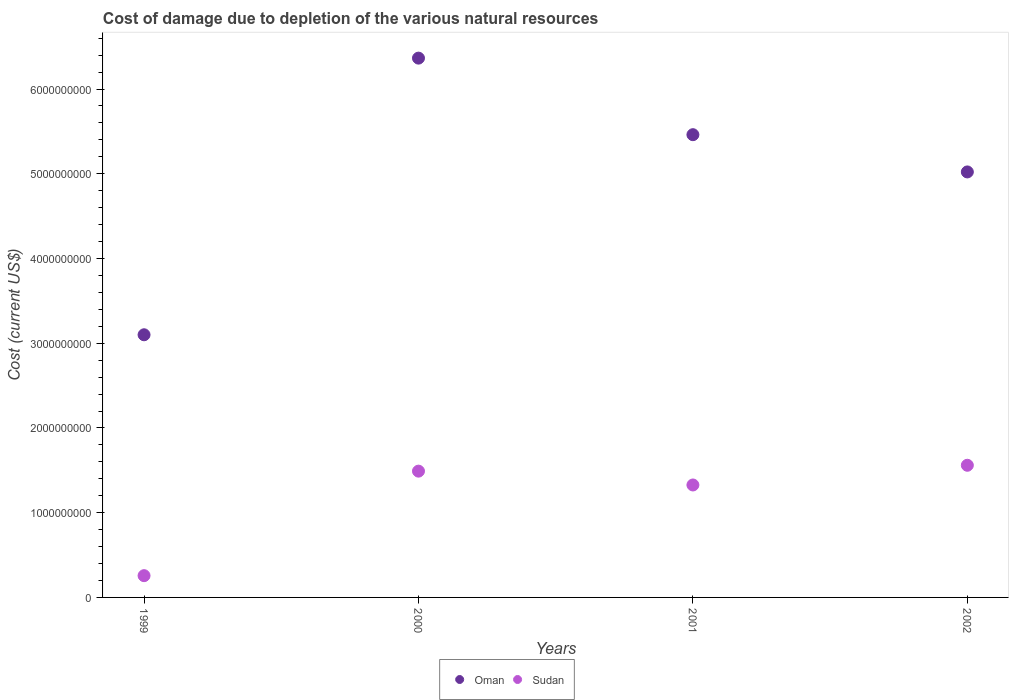How many different coloured dotlines are there?
Provide a succinct answer. 2. What is the cost of damage caused due to the depletion of various natural resources in Sudan in 2001?
Your response must be concise. 1.33e+09. Across all years, what is the maximum cost of damage caused due to the depletion of various natural resources in Sudan?
Give a very brief answer. 1.56e+09. Across all years, what is the minimum cost of damage caused due to the depletion of various natural resources in Oman?
Offer a very short reply. 3.10e+09. In which year was the cost of damage caused due to the depletion of various natural resources in Oman maximum?
Your answer should be compact. 2000. In which year was the cost of damage caused due to the depletion of various natural resources in Oman minimum?
Provide a short and direct response. 1999. What is the total cost of damage caused due to the depletion of various natural resources in Sudan in the graph?
Make the answer very short. 4.63e+09. What is the difference between the cost of damage caused due to the depletion of various natural resources in Sudan in 1999 and that in 2002?
Your answer should be compact. -1.30e+09. What is the difference between the cost of damage caused due to the depletion of various natural resources in Oman in 1999 and the cost of damage caused due to the depletion of various natural resources in Sudan in 2000?
Your answer should be compact. 1.61e+09. What is the average cost of damage caused due to the depletion of various natural resources in Sudan per year?
Make the answer very short. 1.16e+09. In the year 1999, what is the difference between the cost of damage caused due to the depletion of various natural resources in Sudan and cost of damage caused due to the depletion of various natural resources in Oman?
Your answer should be compact. -2.84e+09. What is the ratio of the cost of damage caused due to the depletion of various natural resources in Sudan in 1999 to that in 2002?
Give a very brief answer. 0.16. Is the difference between the cost of damage caused due to the depletion of various natural resources in Sudan in 1999 and 2000 greater than the difference between the cost of damage caused due to the depletion of various natural resources in Oman in 1999 and 2000?
Offer a very short reply. Yes. What is the difference between the highest and the second highest cost of damage caused due to the depletion of various natural resources in Sudan?
Offer a very short reply. 6.93e+07. What is the difference between the highest and the lowest cost of damage caused due to the depletion of various natural resources in Sudan?
Give a very brief answer. 1.30e+09. In how many years, is the cost of damage caused due to the depletion of various natural resources in Oman greater than the average cost of damage caused due to the depletion of various natural resources in Oman taken over all years?
Keep it short and to the point. 3. Is the sum of the cost of damage caused due to the depletion of various natural resources in Oman in 2001 and 2002 greater than the maximum cost of damage caused due to the depletion of various natural resources in Sudan across all years?
Keep it short and to the point. Yes. Does the cost of damage caused due to the depletion of various natural resources in Oman monotonically increase over the years?
Make the answer very short. No. Is the cost of damage caused due to the depletion of various natural resources in Oman strictly less than the cost of damage caused due to the depletion of various natural resources in Sudan over the years?
Your answer should be very brief. No. How many dotlines are there?
Keep it short and to the point. 2. What is the difference between two consecutive major ticks on the Y-axis?
Your response must be concise. 1.00e+09. Where does the legend appear in the graph?
Keep it short and to the point. Bottom center. What is the title of the graph?
Give a very brief answer. Cost of damage due to depletion of the various natural resources. What is the label or title of the Y-axis?
Offer a terse response. Cost (current US$). What is the Cost (current US$) in Oman in 1999?
Ensure brevity in your answer.  3.10e+09. What is the Cost (current US$) of Sudan in 1999?
Provide a short and direct response. 2.57e+08. What is the Cost (current US$) in Oman in 2000?
Give a very brief answer. 6.36e+09. What is the Cost (current US$) of Sudan in 2000?
Your answer should be compact. 1.49e+09. What is the Cost (current US$) in Oman in 2001?
Your answer should be compact. 5.46e+09. What is the Cost (current US$) in Sudan in 2001?
Provide a succinct answer. 1.33e+09. What is the Cost (current US$) in Oman in 2002?
Offer a very short reply. 5.02e+09. What is the Cost (current US$) of Sudan in 2002?
Your response must be concise. 1.56e+09. Across all years, what is the maximum Cost (current US$) of Oman?
Make the answer very short. 6.36e+09. Across all years, what is the maximum Cost (current US$) in Sudan?
Give a very brief answer. 1.56e+09. Across all years, what is the minimum Cost (current US$) of Oman?
Your response must be concise. 3.10e+09. Across all years, what is the minimum Cost (current US$) of Sudan?
Make the answer very short. 2.57e+08. What is the total Cost (current US$) in Oman in the graph?
Offer a very short reply. 1.99e+1. What is the total Cost (current US$) in Sudan in the graph?
Your answer should be compact. 4.63e+09. What is the difference between the Cost (current US$) of Oman in 1999 and that in 2000?
Give a very brief answer. -3.26e+09. What is the difference between the Cost (current US$) in Sudan in 1999 and that in 2000?
Provide a short and direct response. -1.23e+09. What is the difference between the Cost (current US$) in Oman in 1999 and that in 2001?
Your answer should be very brief. -2.36e+09. What is the difference between the Cost (current US$) of Sudan in 1999 and that in 2001?
Your answer should be compact. -1.07e+09. What is the difference between the Cost (current US$) of Oman in 1999 and that in 2002?
Ensure brevity in your answer.  -1.92e+09. What is the difference between the Cost (current US$) in Sudan in 1999 and that in 2002?
Your response must be concise. -1.30e+09. What is the difference between the Cost (current US$) in Oman in 2000 and that in 2001?
Your answer should be compact. 9.03e+08. What is the difference between the Cost (current US$) of Sudan in 2000 and that in 2001?
Offer a very short reply. 1.63e+08. What is the difference between the Cost (current US$) in Oman in 2000 and that in 2002?
Offer a very short reply. 1.34e+09. What is the difference between the Cost (current US$) in Sudan in 2000 and that in 2002?
Your response must be concise. -6.93e+07. What is the difference between the Cost (current US$) in Oman in 2001 and that in 2002?
Ensure brevity in your answer.  4.40e+08. What is the difference between the Cost (current US$) in Sudan in 2001 and that in 2002?
Ensure brevity in your answer.  -2.32e+08. What is the difference between the Cost (current US$) in Oman in 1999 and the Cost (current US$) in Sudan in 2000?
Your answer should be very brief. 1.61e+09. What is the difference between the Cost (current US$) in Oman in 1999 and the Cost (current US$) in Sudan in 2001?
Offer a terse response. 1.77e+09. What is the difference between the Cost (current US$) of Oman in 1999 and the Cost (current US$) of Sudan in 2002?
Offer a terse response. 1.54e+09. What is the difference between the Cost (current US$) of Oman in 2000 and the Cost (current US$) of Sudan in 2001?
Your answer should be very brief. 5.04e+09. What is the difference between the Cost (current US$) of Oman in 2000 and the Cost (current US$) of Sudan in 2002?
Offer a terse response. 4.80e+09. What is the difference between the Cost (current US$) of Oman in 2001 and the Cost (current US$) of Sudan in 2002?
Give a very brief answer. 3.90e+09. What is the average Cost (current US$) of Oman per year?
Give a very brief answer. 4.99e+09. What is the average Cost (current US$) of Sudan per year?
Your answer should be compact. 1.16e+09. In the year 1999, what is the difference between the Cost (current US$) in Oman and Cost (current US$) in Sudan?
Make the answer very short. 2.84e+09. In the year 2000, what is the difference between the Cost (current US$) of Oman and Cost (current US$) of Sudan?
Ensure brevity in your answer.  4.87e+09. In the year 2001, what is the difference between the Cost (current US$) of Oman and Cost (current US$) of Sudan?
Offer a very short reply. 4.13e+09. In the year 2002, what is the difference between the Cost (current US$) in Oman and Cost (current US$) in Sudan?
Provide a short and direct response. 3.46e+09. What is the ratio of the Cost (current US$) in Oman in 1999 to that in 2000?
Keep it short and to the point. 0.49. What is the ratio of the Cost (current US$) of Sudan in 1999 to that in 2000?
Your answer should be very brief. 0.17. What is the ratio of the Cost (current US$) in Oman in 1999 to that in 2001?
Give a very brief answer. 0.57. What is the ratio of the Cost (current US$) of Sudan in 1999 to that in 2001?
Ensure brevity in your answer.  0.19. What is the ratio of the Cost (current US$) of Oman in 1999 to that in 2002?
Keep it short and to the point. 0.62. What is the ratio of the Cost (current US$) in Sudan in 1999 to that in 2002?
Your answer should be very brief. 0.16. What is the ratio of the Cost (current US$) in Oman in 2000 to that in 2001?
Offer a terse response. 1.17. What is the ratio of the Cost (current US$) in Sudan in 2000 to that in 2001?
Provide a short and direct response. 1.12. What is the ratio of the Cost (current US$) in Oman in 2000 to that in 2002?
Your answer should be very brief. 1.27. What is the ratio of the Cost (current US$) in Sudan in 2000 to that in 2002?
Keep it short and to the point. 0.96. What is the ratio of the Cost (current US$) of Oman in 2001 to that in 2002?
Provide a succinct answer. 1.09. What is the ratio of the Cost (current US$) of Sudan in 2001 to that in 2002?
Offer a terse response. 0.85. What is the difference between the highest and the second highest Cost (current US$) in Oman?
Your answer should be very brief. 9.03e+08. What is the difference between the highest and the second highest Cost (current US$) in Sudan?
Your response must be concise. 6.93e+07. What is the difference between the highest and the lowest Cost (current US$) in Oman?
Provide a short and direct response. 3.26e+09. What is the difference between the highest and the lowest Cost (current US$) of Sudan?
Ensure brevity in your answer.  1.30e+09. 